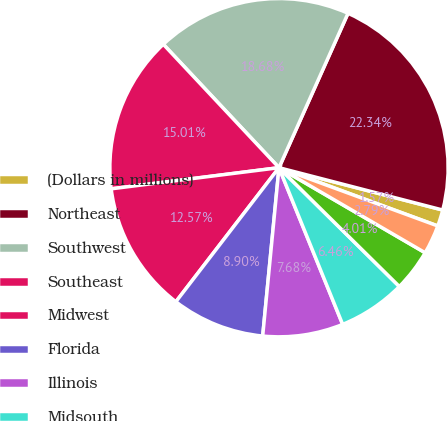Convert chart to OTSL. <chart><loc_0><loc_0><loc_500><loc_500><pie_chart><fcel>(Dollars in millions)<fcel>Northeast<fcel>Southwest<fcel>Southeast<fcel>Midwest<fcel>Florida<fcel>Illinois<fcel>Midsouth<fcel>Northwest<fcel>Non-US<nl><fcel>1.57%<fcel>22.34%<fcel>18.68%<fcel>15.01%<fcel>12.57%<fcel>8.9%<fcel>7.68%<fcel>6.46%<fcel>4.01%<fcel>2.79%<nl></chart> 